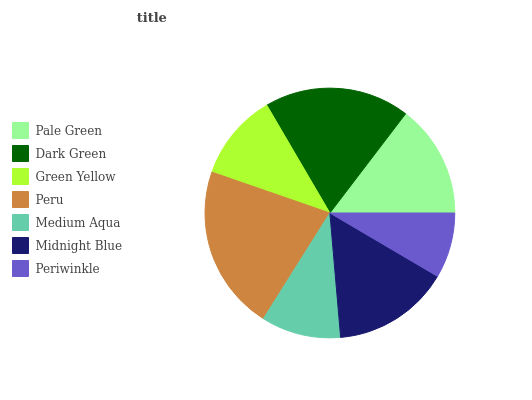Is Periwinkle the minimum?
Answer yes or no. Yes. Is Peru the maximum?
Answer yes or no. Yes. Is Dark Green the minimum?
Answer yes or no. No. Is Dark Green the maximum?
Answer yes or no. No. Is Dark Green greater than Pale Green?
Answer yes or no. Yes. Is Pale Green less than Dark Green?
Answer yes or no. Yes. Is Pale Green greater than Dark Green?
Answer yes or no. No. Is Dark Green less than Pale Green?
Answer yes or no. No. Is Pale Green the high median?
Answer yes or no. Yes. Is Pale Green the low median?
Answer yes or no. Yes. Is Medium Aqua the high median?
Answer yes or no. No. Is Medium Aqua the low median?
Answer yes or no. No. 